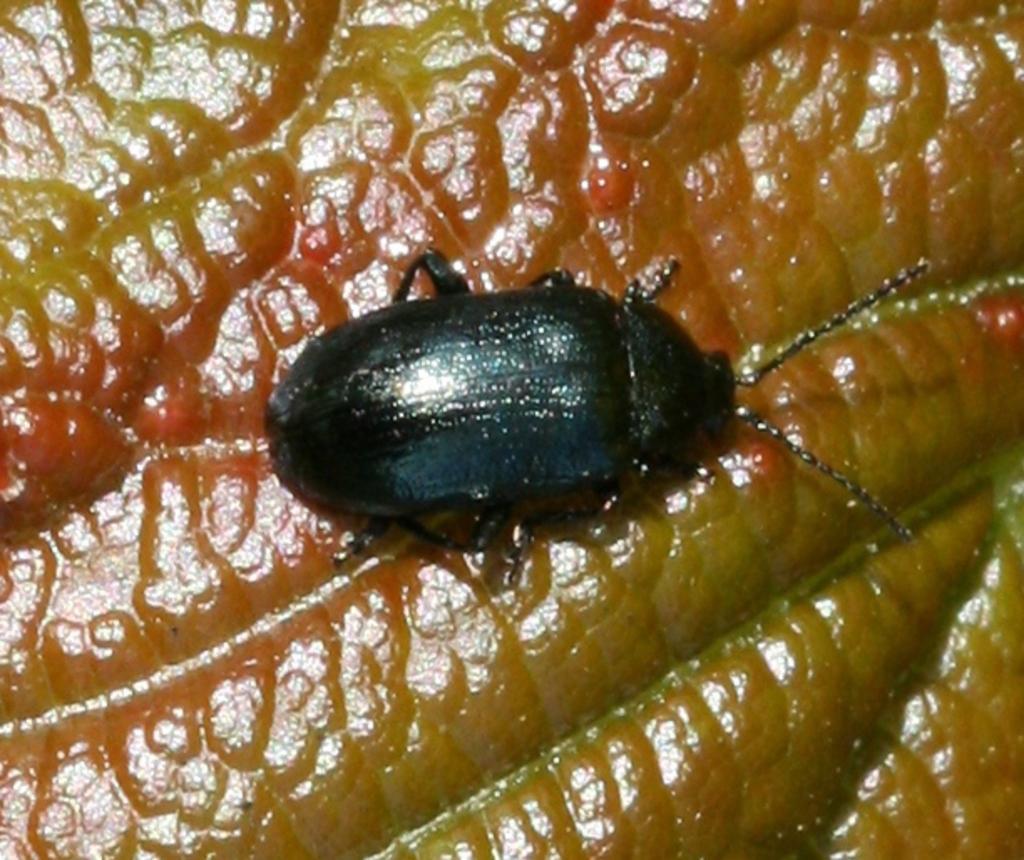Can you describe this image briefly? In this picture we can see black bug is sitting on the brown object. 